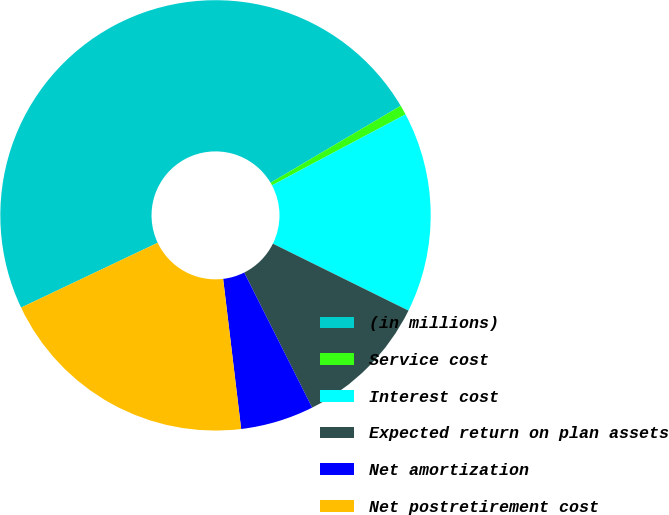Convert chart. <chart><loc_0><loc_0><loc_500><loc_500><pie_chart><fcel>(in millions)<fcel>Service cost<fcel>Interest cost<fcel>Expected return on plan assets<fcel>Net amortization<fcel>Net postretirement cost<nl><fcel>48.55%<fcel>0.73%<fcel>15.07%<fcel>10.29%<fcel>5.51%<fcel>19.85%<nl></chart> 